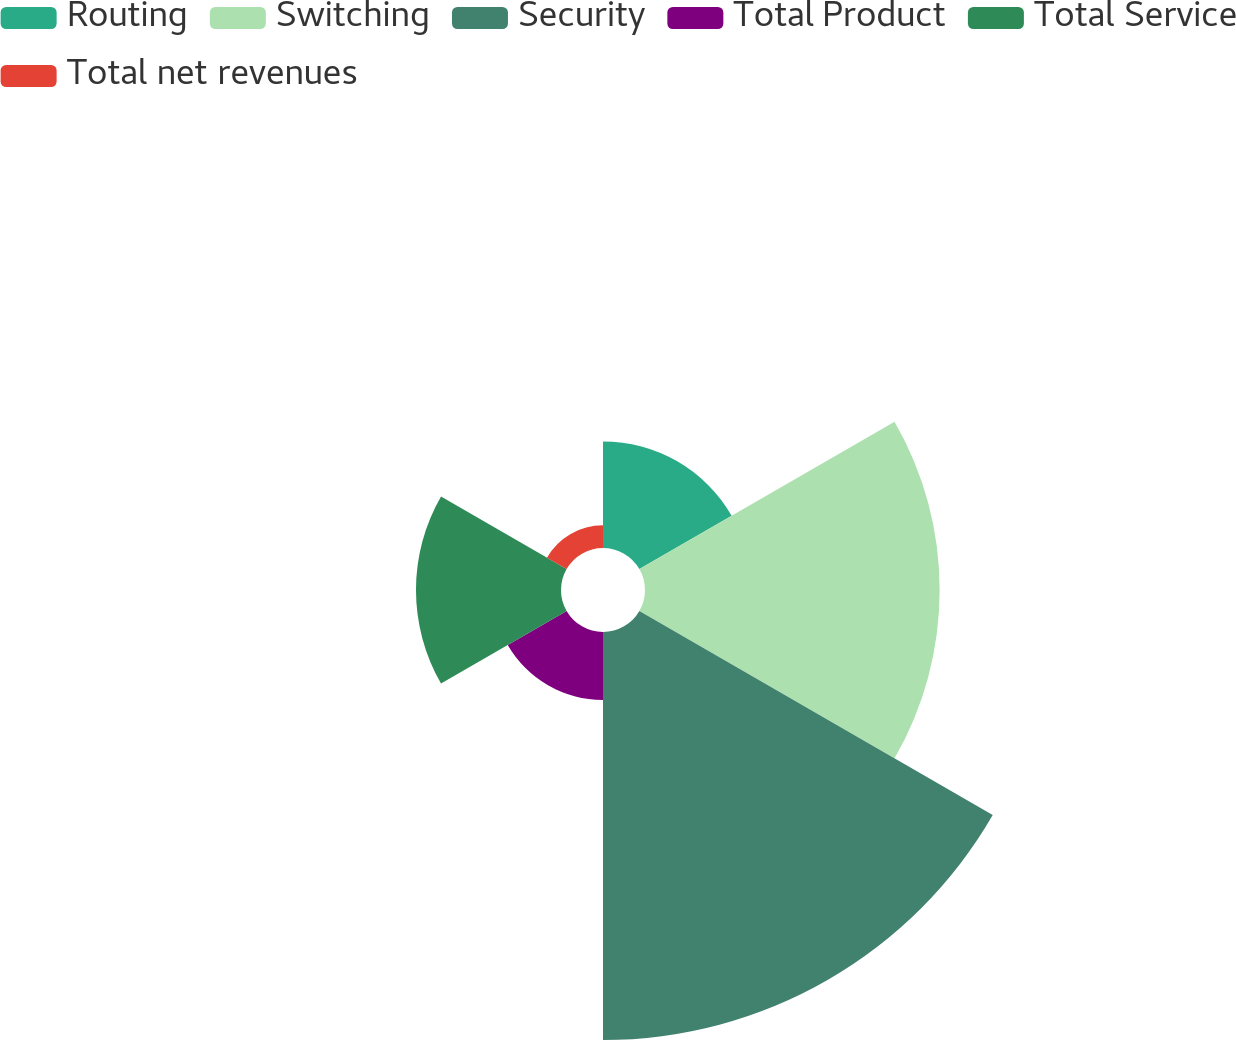Convert chart. <chart><loc_0><loc_0><loc_500><loc_500><pie_chart><fcel>Routing<fcel>Switching<fcel>Security<fcel>Total Product<fcel>Total Service<fcel>Total net revenues<nl><fcel>10.2%<fcel>28.2%<fcel>39.05%<fcel>6.51%<fcel>13.88%<fcel>2.17%<nl></chart> 